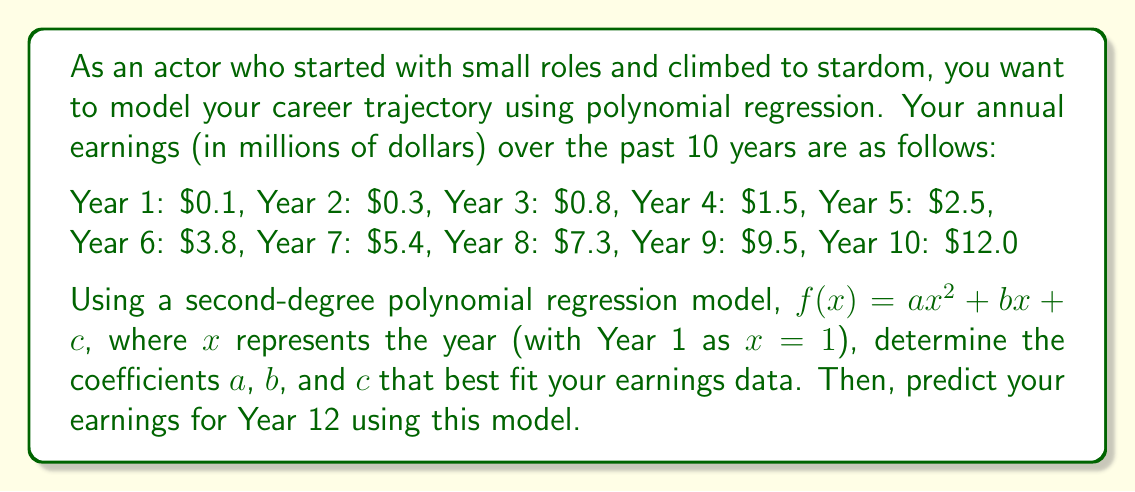Solve this math problem. To solve this problem, we'll use the method of least squares to find the best-fitting second-degree polynomial. We'll set up a system of normal equations and solve for $a$, $b$, and $c$.

Let's first set up our data:
$x_i$ = year number (1 to 10)
$y_i$ = earnings in millions

We need to calculate the following sums:
$$\sum x_i, \sum x_i^2, \sum x_i^3, \sum x_i^4, \sum y_i, \sum x_iy_i, \sum x_i^2y_i$$

Calculating these sums:
$$\sum x_i = 55$$
$$\sum x_i^2 = 385$$
$$\sum x_i^3 = 3025$$
$$\sum x_i^4 = 25333$$
$$\sum y_i = 43.2$$
$$\sum x_iy_i = 334.9$$
$$\sum x_i^2y_i = 2834.5$$

Now, we can set up the normal equations:

$$\begin{cases}
a\sum x_i^4 + b\sum x_i^3 + c\sum x_i^2 = \sum x_i^2y_i \\
a\sum x_i^3 + b\sum x_i^2 + c\sum x_i = \sum x_iy_i \\
a\sum x_i^2 + b\sum x_i + 10c = \sum y_i
\end{cases}$$

Substituting our calculated values:

$$\begin{cases}
25333a + 3025b + 385c = 2834.5 \\
3025a + 385b + 55c = 334.9 \\
385a + 55b + 10c = 43.2
\end{cases}$$

Solving this system of equations (using a calculator or computer algebra system), we get:

$$a \approx 0.1064$$
$$b \approx 0.3682$$
$$c \approx -0.3455$$

Therefore, our polynomial regression model is:

$$f(x) = 0.1064x^2 + 0.3682x - 0.3455$$

To predict earnings for Year 12, we substitute $x = 12$ into our model:

$$f(12) = 0.1064(12)^2 + 0.3682(12) - 0.3455$$
$$f(12) = 0.1064(144) + 4.4184 - 0.3455$$
$$f(12) = 15.3216 + 4.4184 - 0.3455$$
$$f(12) = 19.3945$$
Answer: The coefficients of the second-degree polynomial regression model are:
$a \approx 0.1064$, $b \approx 0.3682$, and $c \approx -0.3455$

The predicted earnings for Year 12 using this model is approximately $19.39 million. 